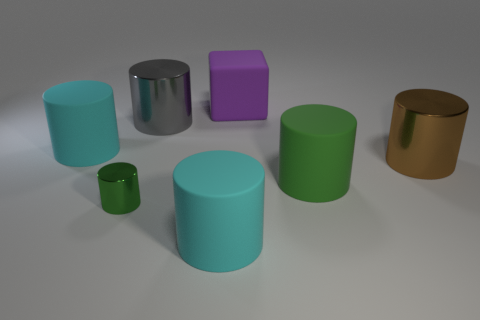Add 1 large brown objects. How many objects exist? 8 Subtract all green cylinders. How many cylinders are left? 4 Subtract all large brown cylinders. How many cylinders are left? 5 Subtract 1 brown cylinders. How many objects are left? 6 Subtract all cylinders. How many objects are left? 1 Subtract all brown cylinders. Subtract all blue spheres. How many cylinders are left? 5 Subtract all cyan balls. How many gray cylinders are left? 1 Subtract all small green matte cubes. Subtract all large rubber blocks. How many objects are left? 6 Add 1 tiny things. How many tiny things are left? 2 Add 7 big cyan cylinders. How many big cyan cylinders exist? 9 